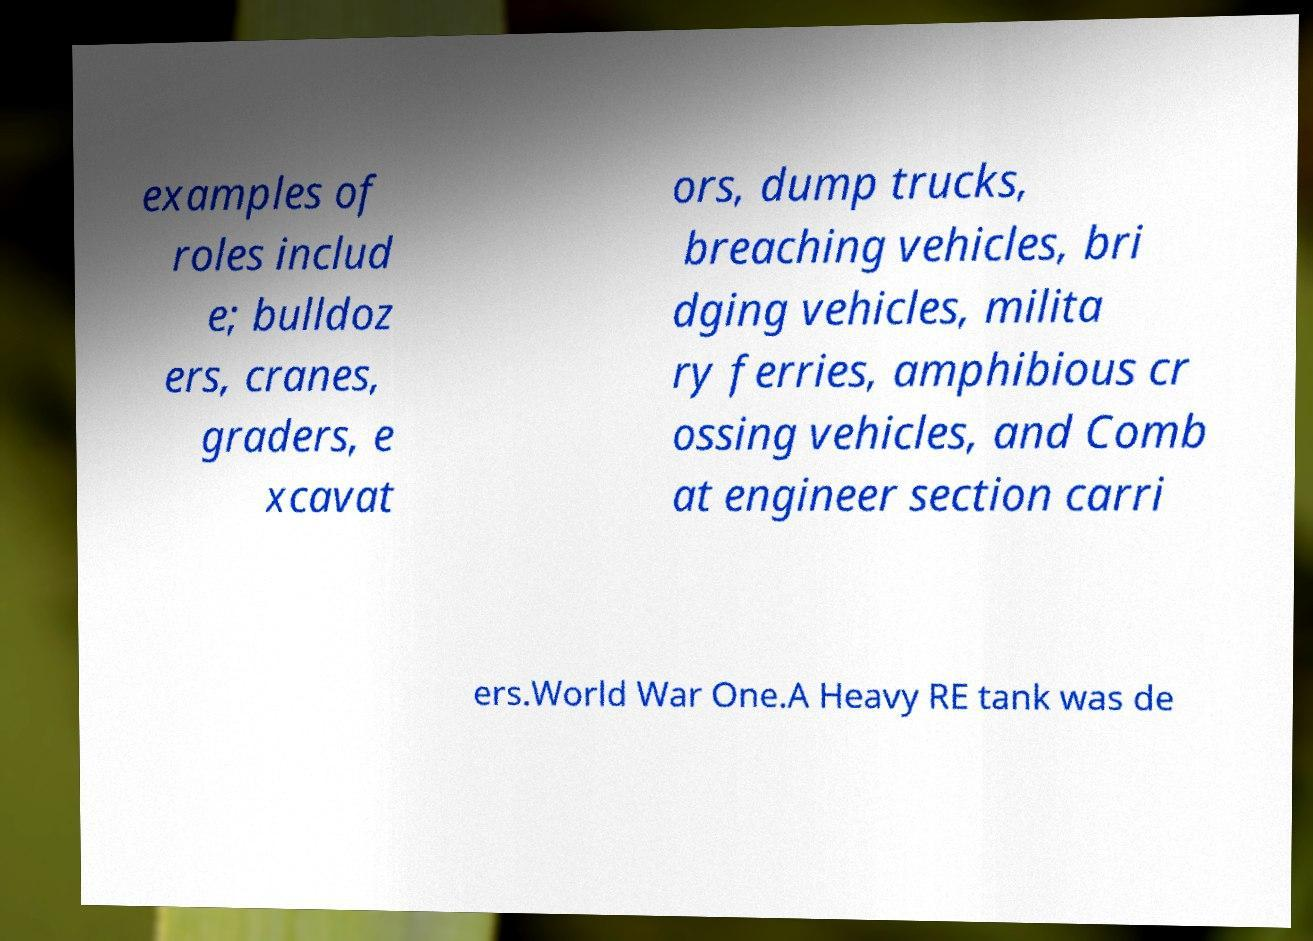Could you assist in decoding the text presented in this image and type it out clearly? examples of roles includ e; bulldoz ers, cranes, graders, e xcavat ors, dump trucks, breaching vehicles, bri dging vehicles, milita ry ferries, amphibious cr ossing vehicles, and Comb at engineer section carri ers.World War One.A Heavy RE tank was de 